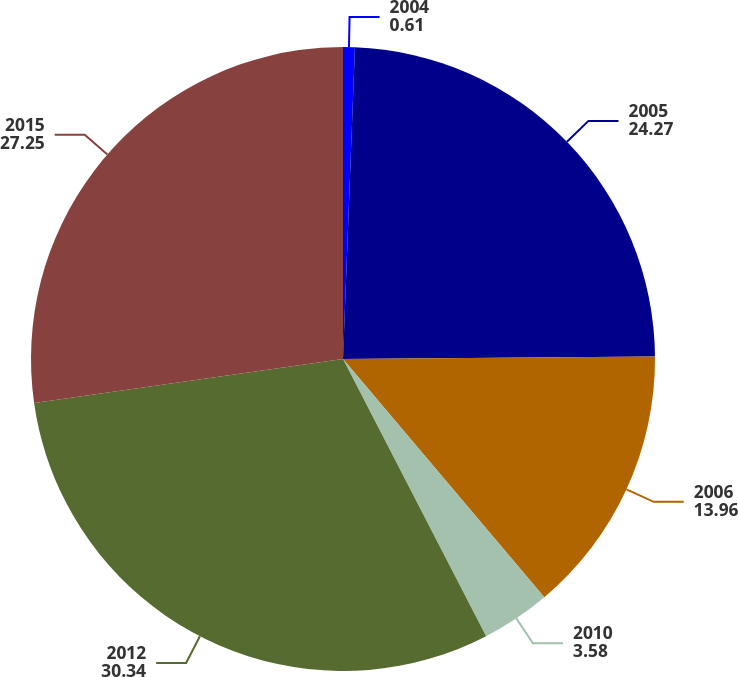<chart> <loc_0><loc_0><loc_500><loc_500><pie_chart><fcel>2004<fcel>2005<fcel>2006<fcel>2010<fcel>2012<fcel>2015<nl><fcel>0.61%<fcel>24.27%<fcel>13.96%<fcel>3.58%<fcel>30.34%<fcel>27.25%<nl></chart> 